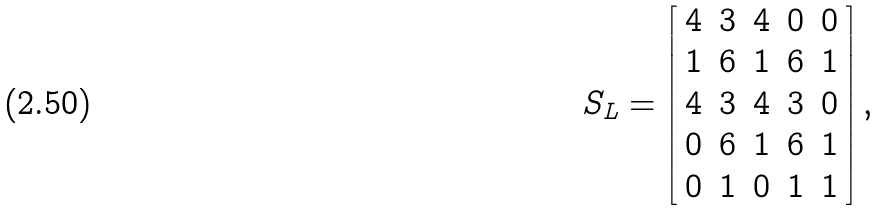<formula> <loc_0><loc_0><loc_500><loc_500>S _ { L } = \left [ \begin{array} { c c c c c } 4 & 3 & 4 & 0 & 0 \\ 1 & 6 & 1 & 6 & 1 \\ 4 & 3 & 4 & 3 & 0 \\ 0 & 6 & 1 & 6 & 1 \\ 0 & 1 & 0 & 1 & 1 \\ \end{array} \right ] ,</formula> 